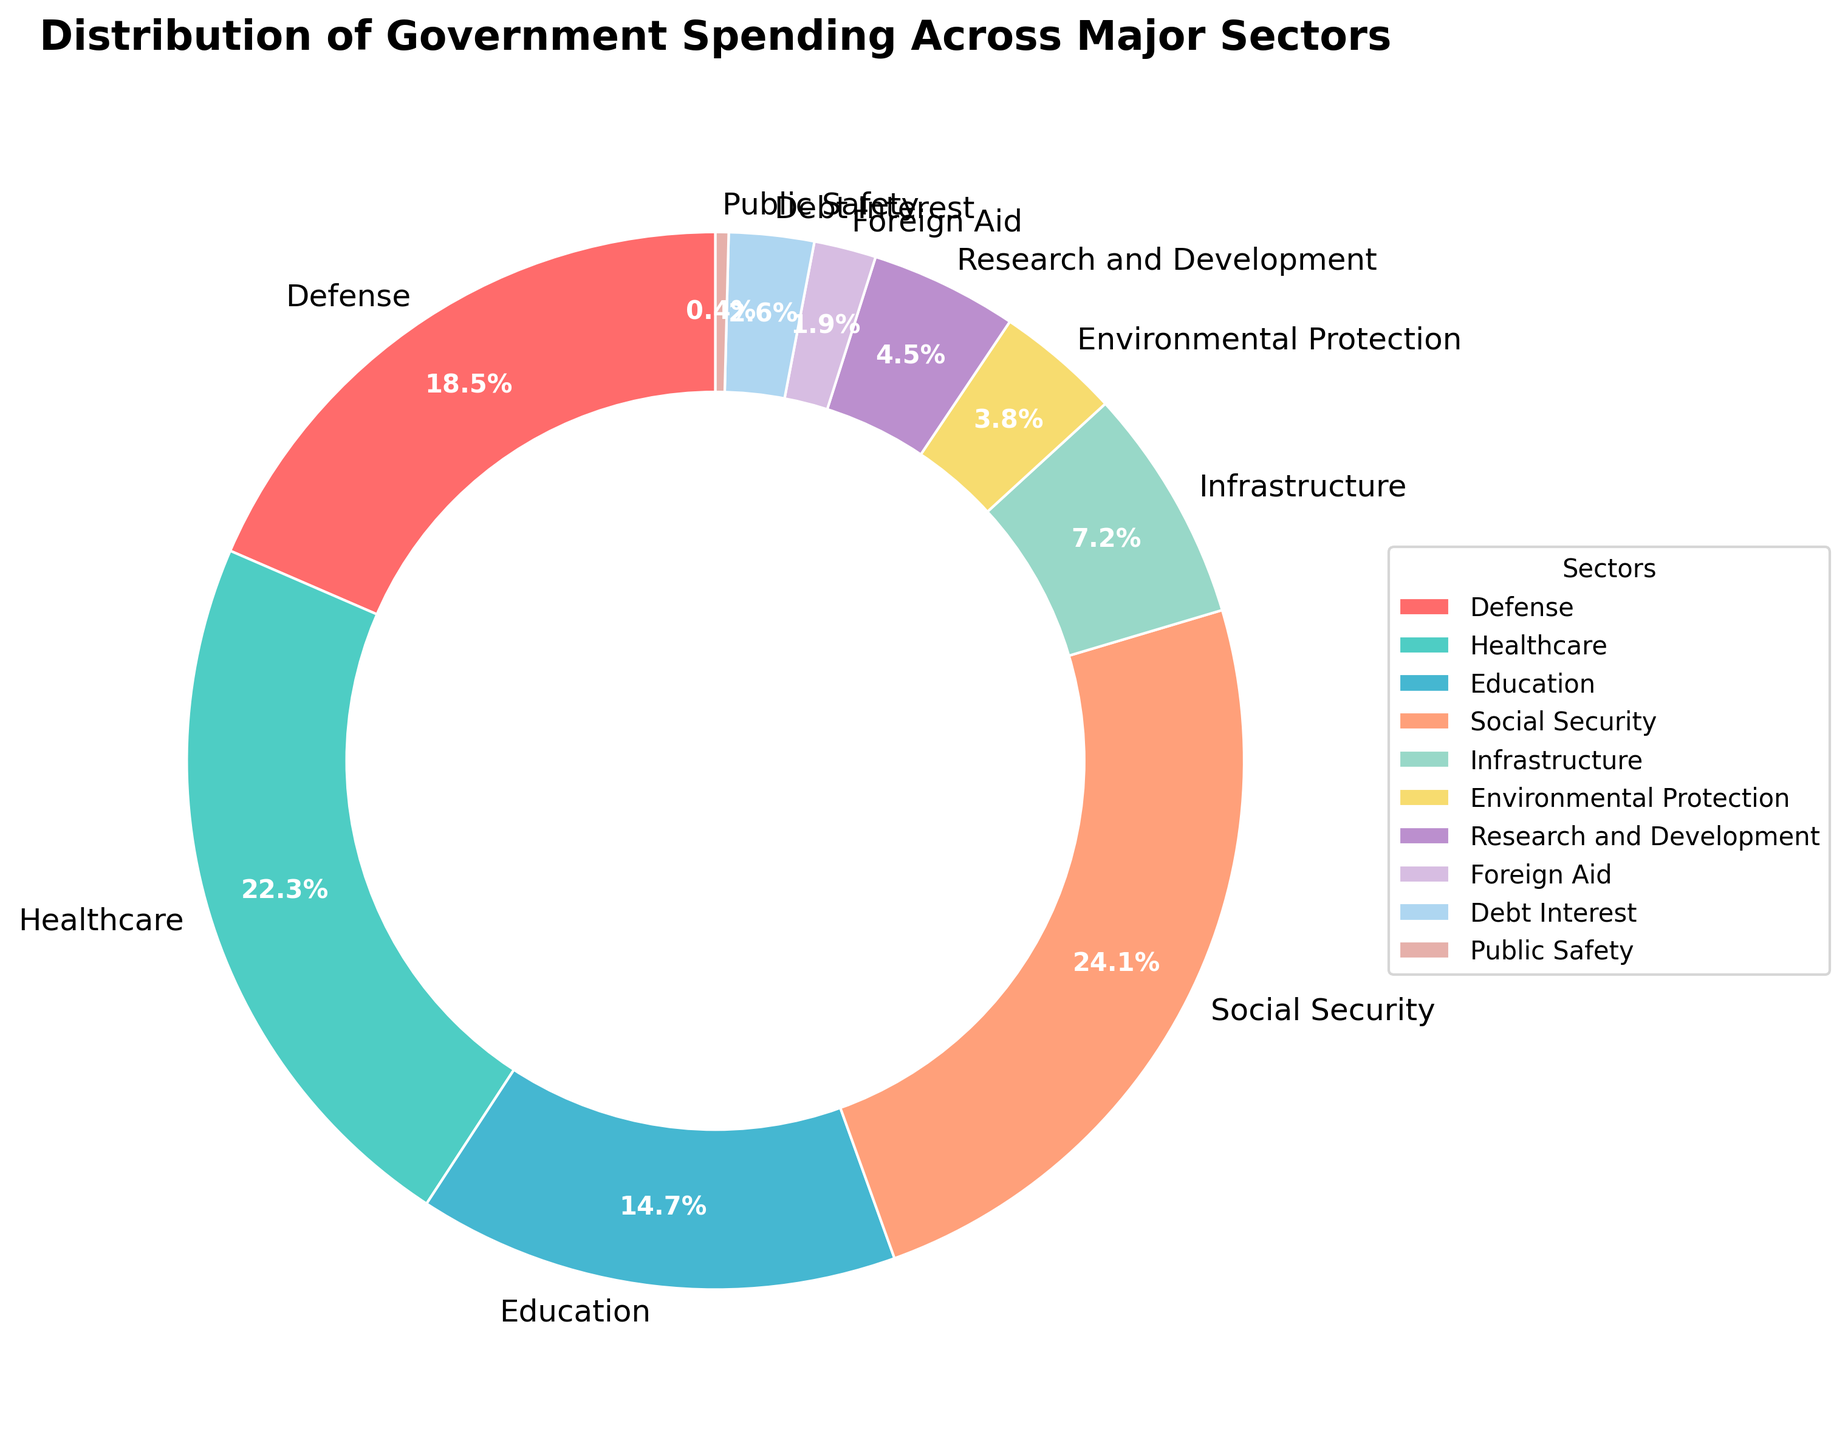What's the largest sector in terms of government spending? To determine the largest sector, we look for the sector with the highest percentage value on the pie chart. The sector with the largest percentage in the figure is Social Security, with 24.1%.
Answer: Social Security What's the combined percentage of government spending on Defense and Education? To calculate the combined percentage, we add the percentages for Defense and Education shown in the figure. Defense is 18.5%, and Education is 14.7%. So, 18.5% + 14.7% equals 33.2%.
Answer: 33.2% How does the percentage of spending on Healthcare compare to that on Infrastructure? To compare the two, we subtract the percentage of Infrastructure from Healthcare. Healthcare has 22.3%, and Infrastructure has 7.2%. So, 22.3% - 7.2% equals 15.1%.
Answer: 15.1% higher Which sectors have less than 5% government spending each? We identify sectors with percentages less than 5% by glancing at the values in the pie chart. The sectors are Environmental Protection (3.8%), Research and Development (4.5%), Foreign Aid (1.9%), Debt Interest (2.6%), and Public Safety (0.4%).
Answer: Environmental Protection, Research and Development, Foreign Aid, Debt Interest, Public Safety What is the visual indication used to differentiate each sector in the pie chart? The pie chart uses different colors to visually distinguish each sector. Each slice is a different color, with a legend on the side matching each color to its respective sector name.
Answer: Different colors What is the combined spending percentage on sectors related to public welfare, such as Social Security and Healthcare? To calculate the combined spending percentage, sum the percentages for Social Security and Healthcare. Social Security is 24.1%, and Healthcare is 22.3%. So, 24.1% + 22.3% equals 46.4%.
Answer: 46.4% How does spending on Research and Development (R&D) compare to Foreign Aid? To compare the spending on R&D to Foreign Aid, we subtract the percentage of Foreign Aid from R&D. R&D has 4.5%, and Foreign Aid has 1.9%. So, 4.5% - 1.9% equals 2.6%.
Answer: 2.6% higher What's the visual representation used to give more importance to each sector's percentage in the chart? The chart adds percentage labels to each sector slice, displaying the specific percentage within the slice to emphasize the sector's share in government spending.
Answer: Percentage labels 